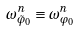Convert formula to latex. <formula><loc_0><loc_0><loc_500><loc_500>\omega _ { \tilde { \varphi } _ { 0 } } ^ { n } \equiv \omega _ { \varphi _ { 0 } } ^ { n }</formula> 